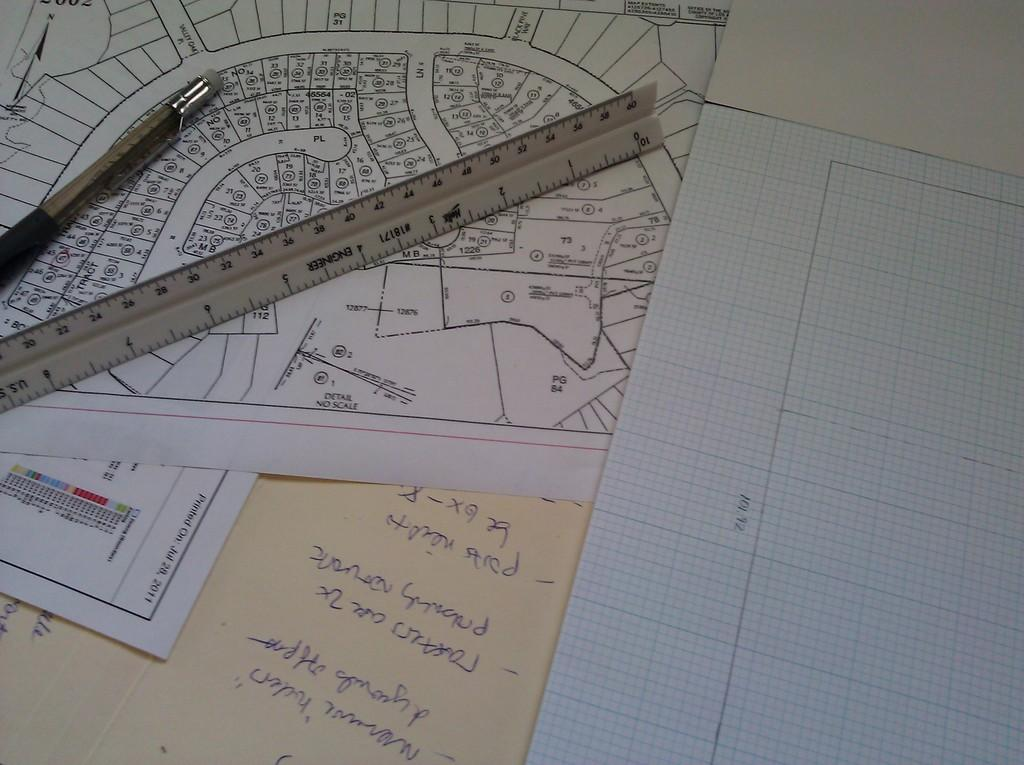<image>
Offer a succinct explanation of the picture presented. Plans for a neighborhood are laid on top of one another with one printed on Jul 28, 2011. 